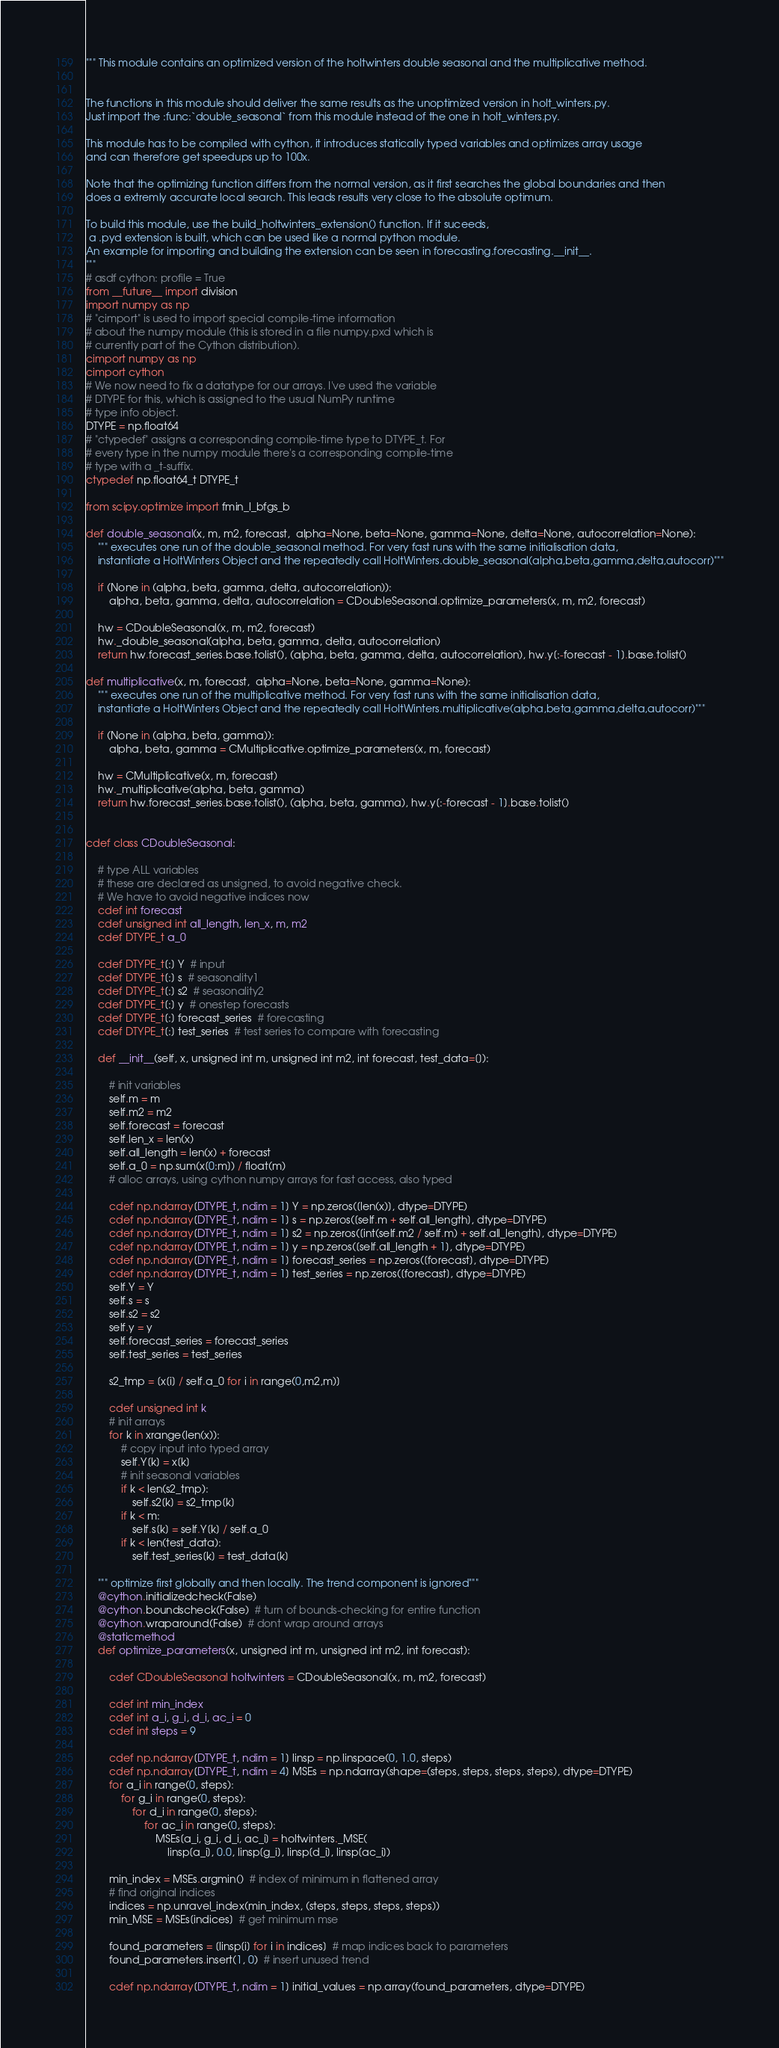Convert code to text. <code><loc_0><loc_0><loc_500><loc_500><_Cython_>""" This module contains an optimized version of the holtwinters double seasonal and the multiplicative method.


The functions in this module should deliver the same results as the unoptimized version in holt_winters.py.
Just import the :func:`double_seasonal` from this module instead of the one in holt_winters.py.

This module has to be compiled with cython, it introduces statically typed variables and optimizes array usage
and can therefore get speedups up to 100x.

Note that the optimizing function differs from the normal version, as it first searches the global boundaries and then
does a extremly accurate local search. This leads results very close to the absolute optimum.

To build this module, use the build_holtwinters_extension() function. If it suceeds,
 a .pyd extension is built, which can be used like a normal python module.
An example for importing and building the extension can be seen in forecasting.forecasting.__init__.
"""
# asdf cython: profile = True
from __future__ import division
import numpy as np
# "cimport" is used to import special compile-time information
# about the numpy module (this is stored in a file numpy.pxd which is
# currently part of the Cython distribution).
cimport numpy as np
cimport cython
# We now need to fix a datatype for our arrays. I've used the variable
# DTYPE for this, which is assigned to the usual NumPy runtime
# type info object.
DTYPE = np.float64
# "ctypedef" assigns a corresponding compile-time type to DTYPE_t. For
# every type in the numpy module there's a corresponding compile-time
# type with a _t-suffix.
ctypedef np.float64_t DTYPE_t

from scipy.optimize import fmin_l_bfgs_b

def double_seasonal(x, m, m2, forecast,  alpha=None, beta=None, gamma=None, delta=None, autocorrelation=None):
    """ executes one run of the double_seasonal method. For very fast runs with the same initialisation data, 
    instantiate a HoltWinters Object and the repeatedly call HoltWinters.double_seasonal(alpha,beta,gamma,delta,autocorr)"""

    if (None in (alpha, beta, gamma, delta, autocorrelation)):
        alpha, beta, gamma, delta, autocorrelation = CDoubleSeasonal.optimize_parameters(x, m, m2, forecast)

    hw = CDoubleSeasonal(x, m, m2, forecast)
    hw._double_seasonal(alpha, beta, gamma, delta, autocorrelation)
    return hw.forecast_series.base.tolist(), (alpha, beta, gamma, delta, autocorrelation), hw.y[:-forecast - 1].base.tolist()

def multiplicative(x, m, forecast,  alpha=None, beta=None, gamma=None):
    """ executes one run of the multiplicative method. For very fast runs with the same initialisation data, 
    instantiate a HoltWinters Object and the repeatedly call HoltWinters.multiplicative(alpha,beta,gamma,delta,autocorr)"""

    if (None in (alpha, beta, gamma)):
        alpha, beta, gamma = CMultiplicative.optimize_parameters(x, m, forecast)

    hw = CMultiplicative(x, m, forecast)
    hw._multiplicative(alpha, beta, gamma)
    return hw.forecast_series.base.tolist(), (alpha, beta, gamma), hw.y[:-forecast - 1].base.tolist()


cdef class CDoubleSeasonal:

    # type ALL variables
    # these are declared as unsigned, to avoid negative check.
    # We have to avoid negative indices now
    cdef int forecast
    cdef unsigned int all_length, len_x, m, m2
    cdef DTYPE_t a_0

    cdef DTYPE_t[:] Y  # input
    cdef DTYPE_t[:] s  # seasonality1
    cdef DTYPE_t[:] s2  # seasonality2
    cdef DTYPE_t[:] y  # onestep forecasts
    cdef DTYPE_t[:] forecast_series  # forecasting
    cdef DTYPE_t[:] test_series  # test series to compare with forecasting

    def __init__(self, x, unsigned int m, unsigned int m2, int forecast, test_data=[]):

        # init variables
        self.m = m
        self.m2 = m2
        self.forecast = forecast
        self.len_x = len(x)
        self.all_length = len(x) + forecast
        self.a_0 = np.sum(x[0:m]) / float(m)
        # alloc arrays, using cython numpy arrays for fast access, also typed

        cdef np.ndarray[DTYPE_t, ndim = 1] Y = np.zeros([len(x)], dtype=DTYPE)
        cdef np.ndarray[DTYPE_t, ndim = 1] s = np.zeros([self.m + self.all_length], dtype=DTYPE)
        cdef np.ndarray[DTYPE_t, ndim = 1] s2 = np.zeros([int(self.m2 / self.m) + self.all_length], dtype=DTYPE)
        cdef np.ndarray[DTYPE_t, ndim = 1] y = np.zeros([self.all_length + 1], dtype=DTYPE)
        cdef np.ndarray[DTYPE_t, ndim = 1] forecast_series = np.zeros([forecast], dtype=DTYPE)
        cdef np.ndarray[DTYPE_t, ndim = 1] test_series = np.zeros([forecast], dtype=DTYPE)
        self.Y = Y
        self.s = s
        self.s2 = s2
        self.y = y
        self.forecast_series = forecast_series
        self.test_series = test_series
        
        s2_tmp = [x[i] / self.a_0 for i in range(0,m2,m)]

        cdef unsigned int k
        # init arrays
        for k in xrange(len(x)):
            # copy input into typed array
            self.Y[k] = x[k]
            # init seasonal variables
            if k < len(s2_tmp):
                self.s2[k] = s2_tmp[k]
            if k < m:
                self.s[k] = self.Y[k] / self.a_0
            if k < len(test_data):
                self.test_series[k] = test_data[k]

    """ optimize first globally and then locally. The trend component is ignored"""
    @cython.initializedcheck(False)
    @cython.boundscheck(False)  # turn of bounds-checking for entire function
    @cython.wraparound(False)  # dont wrap around arrays
    @staticmethod
    def optimize_parameters(x, unsigned int m, unsigned int m2, int forecast):

        cdef CDoubleSeasonal holtwinters = CDoubleSeasonal(x, m, m2, forecast)

        cdef int min_index
        cdef int a_i, g_i, d_i, ac_i = 0
        cdef int steps = 9

        cdef np.ndarray[DTYPE_t, ndim = 1] linsp = np.linspace(0, 1.0, steps)
        cdef np.ndarray[DTYPE_t, ndim = 4] MSEs = np.ndarray(shape=(steps, steps, steps, steps), dtype=DTYPE)
        for a_i in range(0, steps):
            for g_i in range(0, steps):
                for d_i in range(0, steps):
                    for ac_i in range(0, steps):
                        MSEs[a_i, g_i, d_i, ac_i] = holtwinters._MSE(
                            linsp[a_i], 0.0, linsp[g_i], linsp[d_i], linsp[ac_i])

        min_index = MSEs.argmin()  # index of minimum in flattened array
        # find original indices
        indices = np.unravel_index(min_index, (steps, steps, steps, steps))
        min_MSE = MSEs[indices]  # get minimum mse

        found_parameters = [linsp[i] for i in indices]  # map indices back to parameters
        found_parameters.insert(1, 0)  # insert unused trend

        cdef np.ndarray[DTYPE_t, ndim = 1] initial_values = np.array(found_parameters, dtype=DTYPE)</code> 